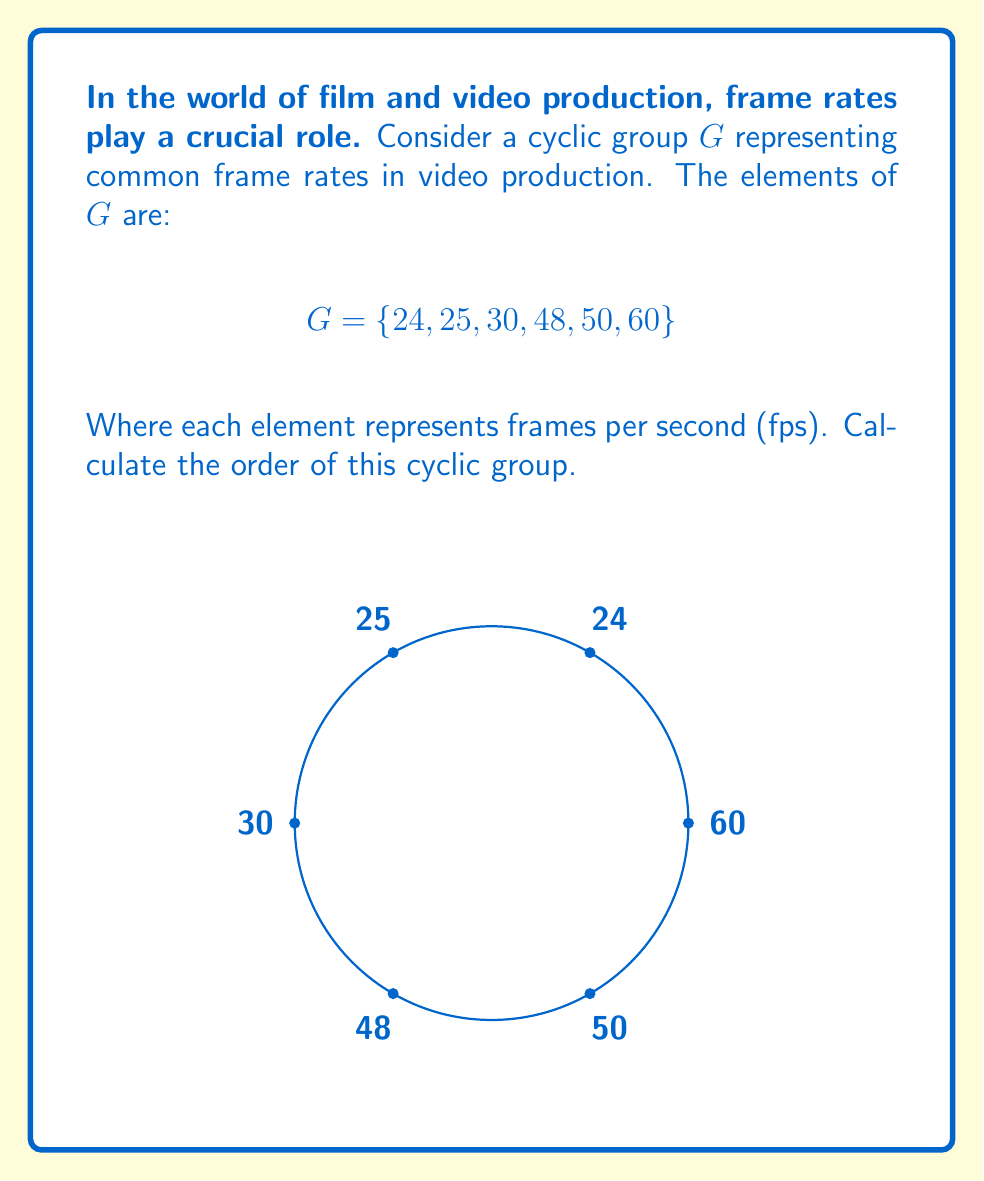Help me with this question. To calculate the order of a cyclic group, we need to find the smallest positive integer $n$ such that $g^n = e$ (the identity element) for any generator $g$ of the group.

In this case, we're dealing with a finite cyclic group representing frame rates. Let's approach this step-by-step:

1) First, we need to identify the generator of the group. In this case, we can use 24 fps as our generator.

2) We then need to find the least common multiple (LCM) of all the elements in the group, as this will give us the number of "rotations" needed to return to the starting point in the cycle.

3) Let's calculate the LCM of 24, 25, 30, 48, 50, and 60:
   
   $LCM(24, 25, 30, 48, 50, 60) = 600$

4) This means that after 600 "steps" or "rotations", we will return to our starting point in the cycle, regardless of which element we start with.

5) Therefore, the order of this cyclic group is 600.

In the context of video production, this means that all these frame rates will synchronize every 600 frames, which could be useful for editing or syncing multiple video sources with different frame rates.
Answer: 600 